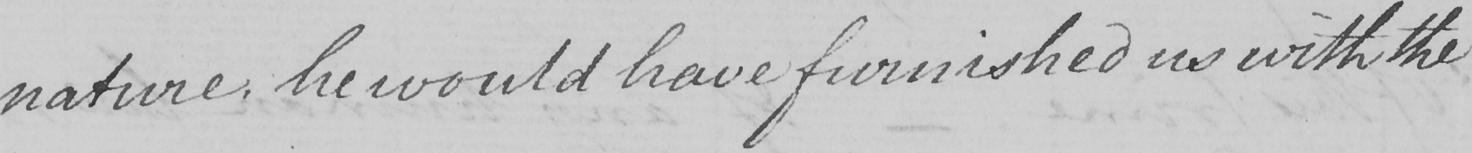Please provide the text content of this handwritten line. nature , he would have furnished us with the 